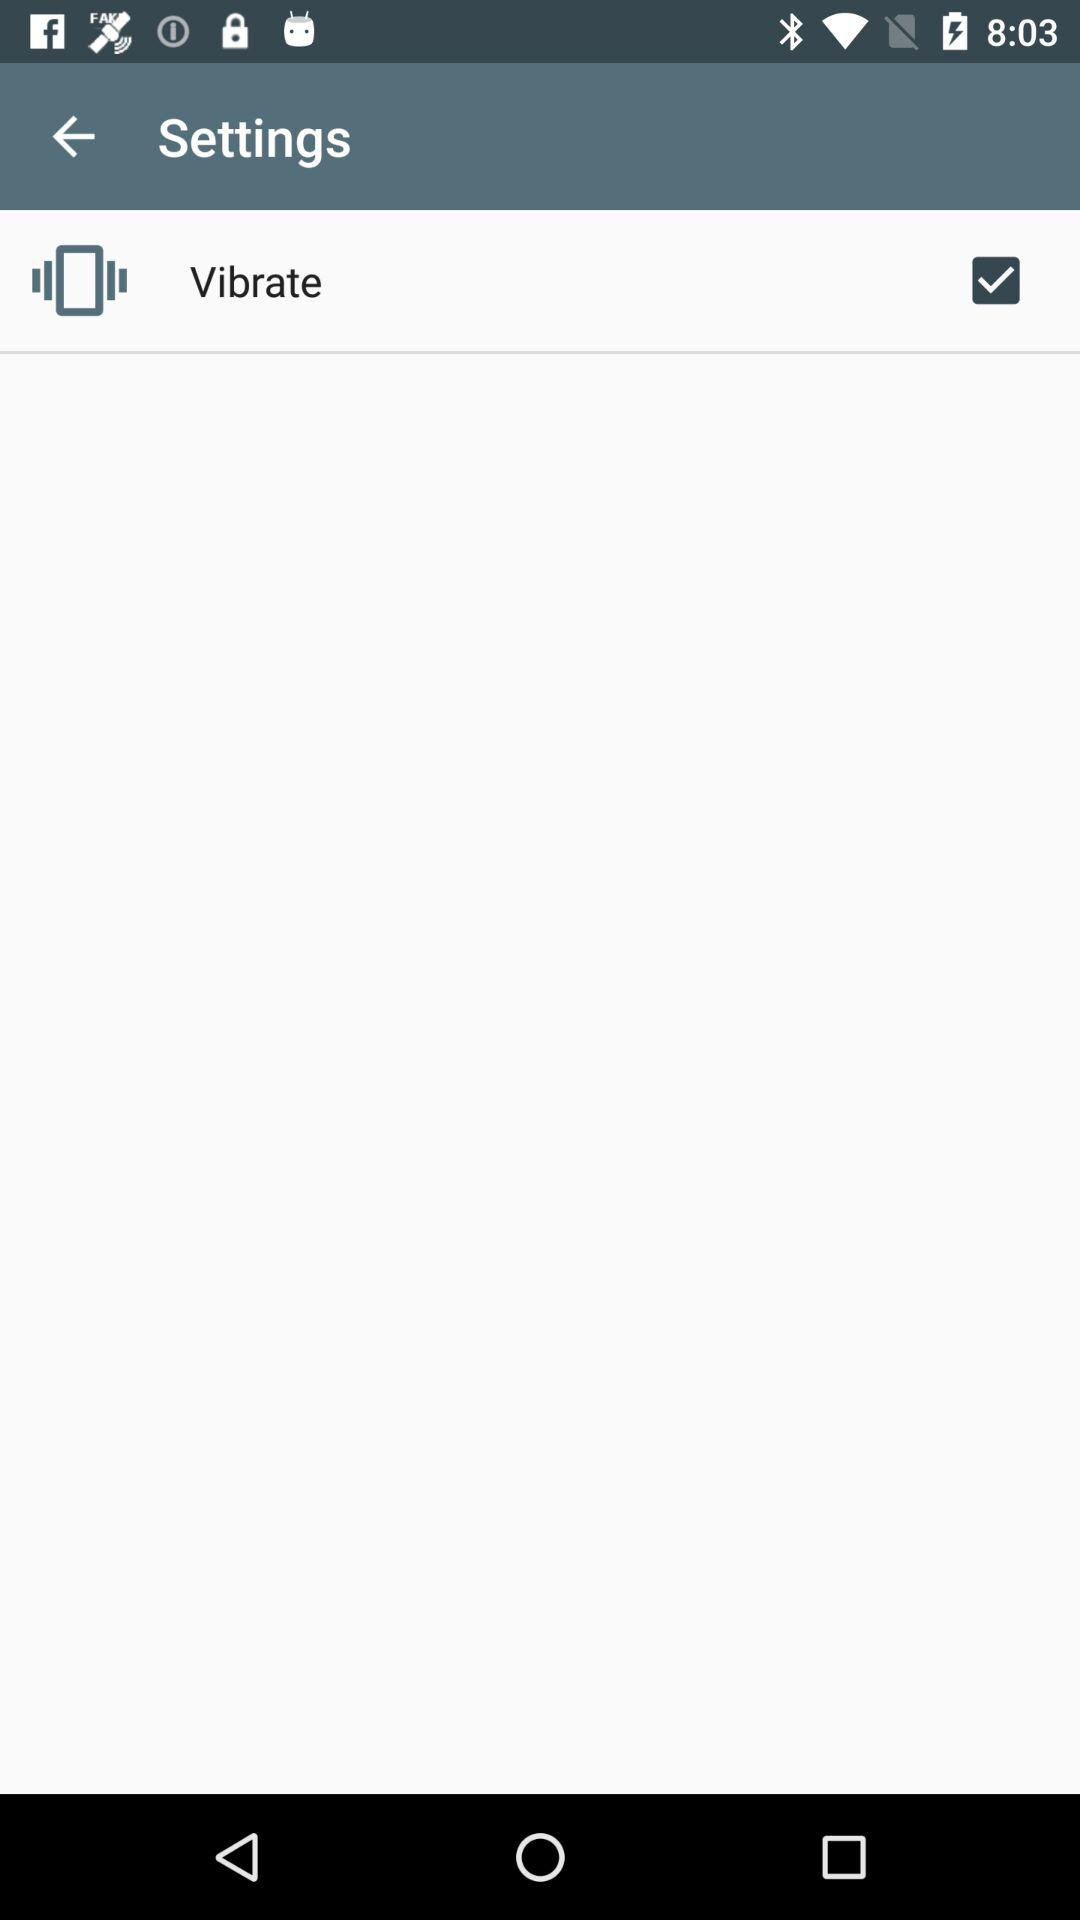What is the status of "Vibrate"? The status is "on". 